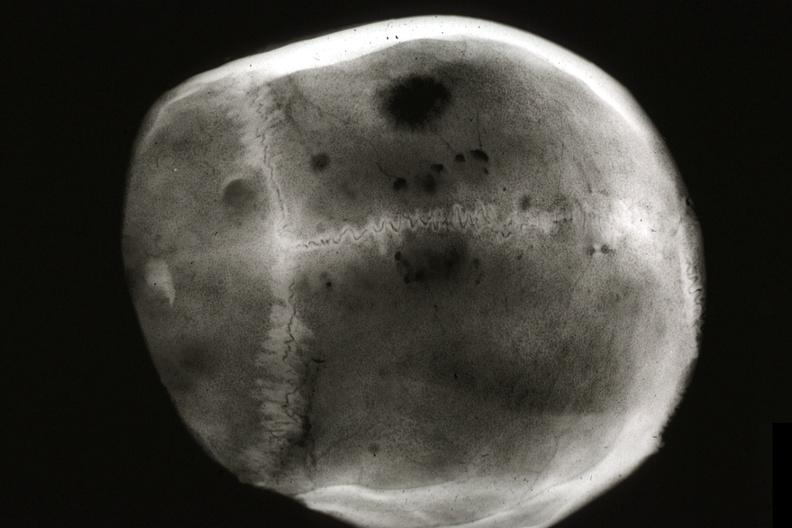what does this image show?
Answer the question using a single word or phrase. X-ray skull cap multiple lytic lesions prostate adenocarcinoma 